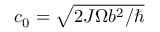<formula> <loc_0><loc_0><loc_500><loc_500>c _ { 0 } = \sqrt { 2 J \Omega b ^ { 2 } / }</formula> 